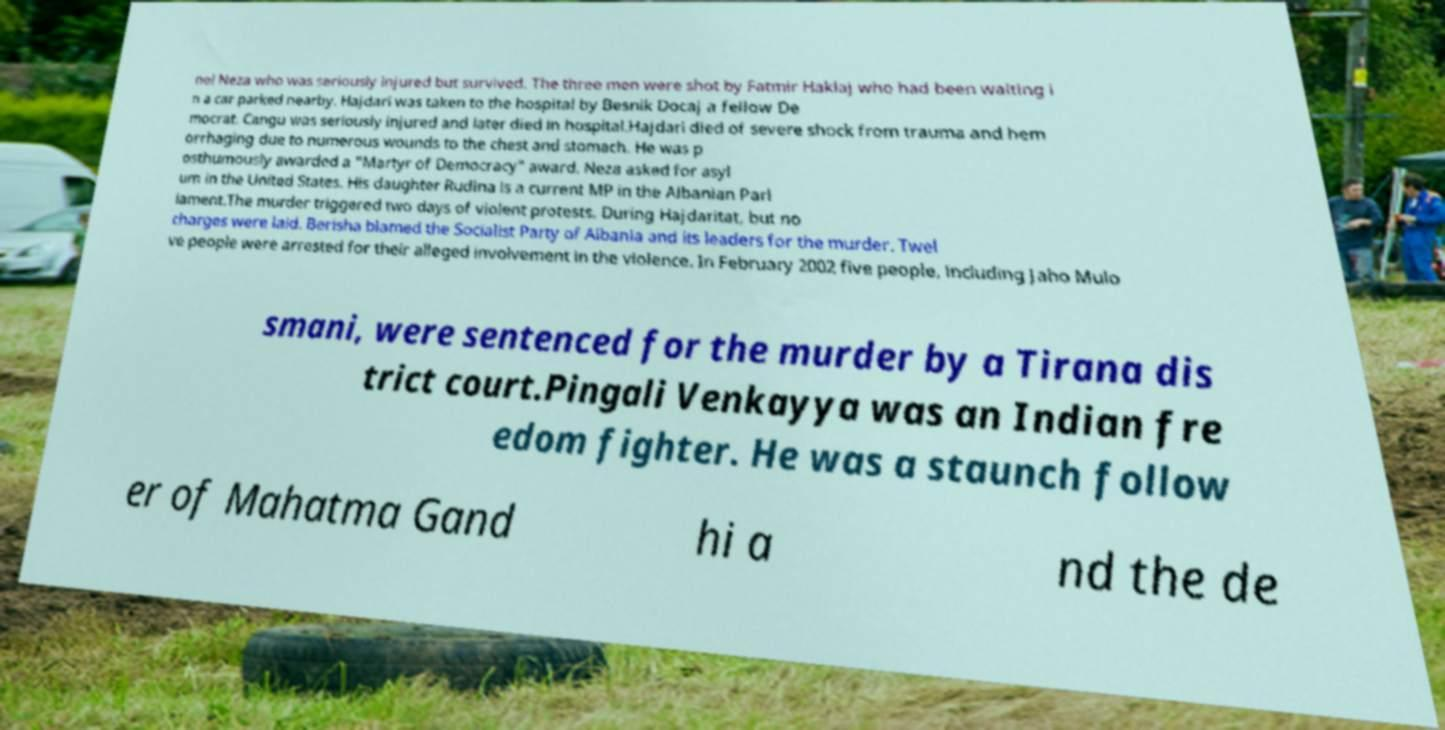Could you extract and type out the text from this image? nel Neza who was seriously injured but survived. The three men were shot by Fatmir Haklaj who had been waiting i n a car parked nearby. Hajdari was taken to the hospital by Besnik Docaj a fellow De mocrat. Cangu was seriously injured and later died in hospital.Hajdari died of severe shock from trauma and hem orrhaging due to numerous wounds to the chest and stomach. He was p osthumously awarded a "Martyr of Democracy" award. Neza asked for asyl um in the United States. His daughter Rudina is a current MP in the Albanian Parl iament.The murder triggered two days of violent protests. During Hajdaritat, but no charges were laid. Berisha blamed the Socialist Party of Albania and its leaders for the murder. Twel ve people were arrested for their alleged involvement in the violence. In February 2002 five people, including Jaho Mulo smani, were sentenced for the murder by a Tirana dis trict court.Pingali Venkayya was an Indian fre edom fighter. He was a staunch follow er of Mahatma Gand hi a nd the de 